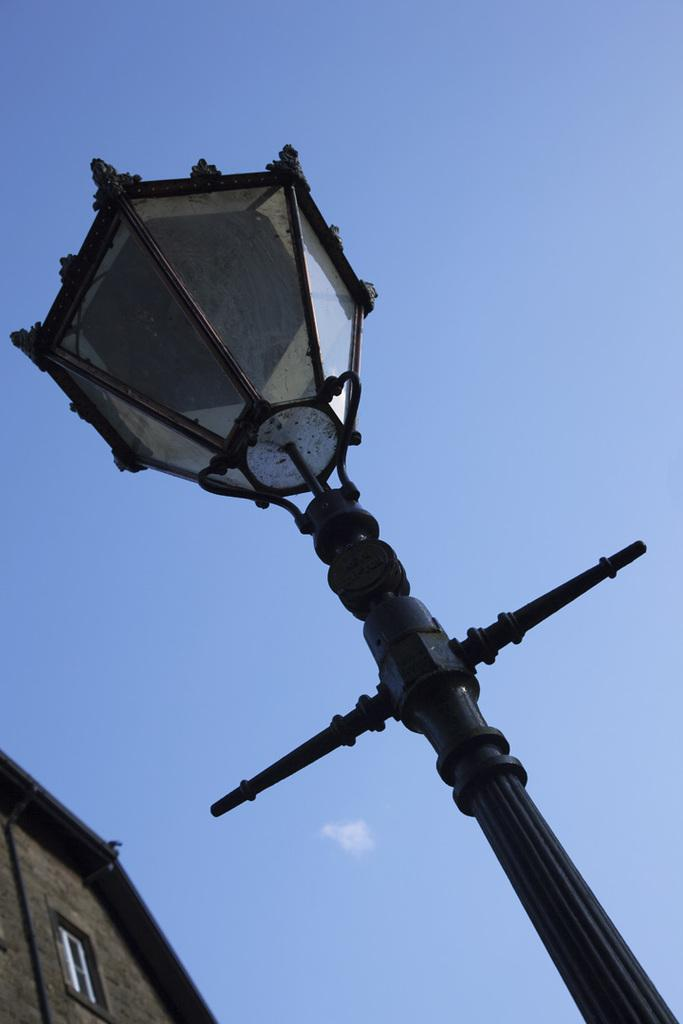What structure can be seen in the image? There is a light pole in the image. What is located to the left of the image? There is a building to the left of the image. What can be seen in the background of the image? The sky is visible in the background of the image. What type of sponge is hanging from the light pole in the image? There is no sponge present in the image; it features a light pole and a building. Can you tell me how many eggnogs are visible in the image? There are no eggnogs present in the image. 